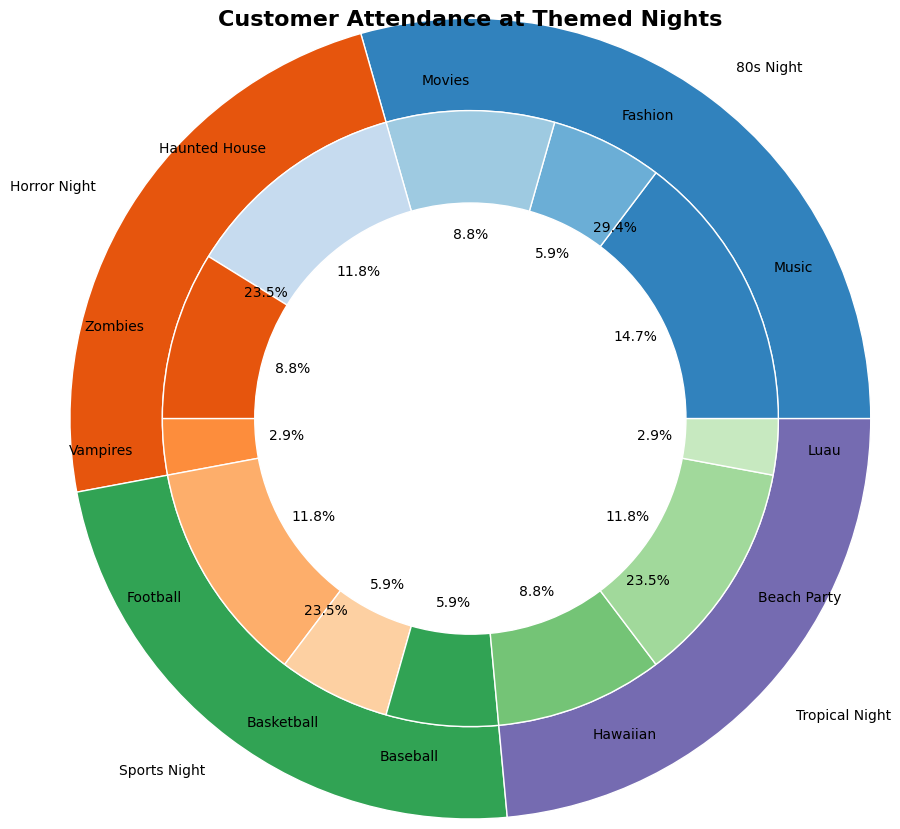Which theme has the highest overall attendance? To find the highest overall attendance, look at the outer pie chart. Compare the sizes of the slices labeled with the themes. The largest slice represents the theme with the highest attendance.
Answer: 80s Night What is the combined percentage of Music and Fashion sub-themes in 80s Night? First, find the percentages of the Music and Fashion sub-themes in the inner pie chart. Sum these percentages: Music (25%) + Fashion (10%) = 35%.
Answer: 35% Between Horror Night and Sports Night, which has a larger percentage of attendance overall? Compare the sizes of the outer slices labeled Horror Night and Sports Night. The larger slice indicates the theme with a higher percentage of attendance.
Answer: Horror Night What is the smallest sub-theme in terms of percentage, and which theme does it belong to? Identify the smallest slice in the inner ring, which represents the smallest sub-theme percentage. Check the label of this slice to find the sub-theme and its corresponding theme.
Answer: Vampires, Horror Night Compare the attendance of Hawaiian sub-theme and Baseball sub-theme. Which one is larger? Look at the sizes of the slices for the Hawaiian and Baseball sub-themes in the inner pie chart. The larger slice indicates the sub-theme with higher attendance.
Answer: Beach Party What is the total percentage of attendance for every Tropical Night sub-theme? Sum the percentages of all sub-themes under Tropical Night: Hawaiian (15%) + Beach Party (20%) + Luau (5%) = 40%.
Answer: 40% Is the combined attendance of Football and Basketball sub-themes more than the overall attendance of Horror Night? First, sum the percentages of the Football (20%) and Basketball (10%) sub-themes: 20% + 10% = 30%. Compare this sum to the overall attendance of Horror Night (40%).
Answer: No Which sub-theme constitutes the largest percentage in the Horror Night theme? Find the largest slice within the Horror Night portion of the inner pie chart and read its label.
Answer: Haunted House What percentage of customer attendance does the Luau sub-theme represent? Locate the Luau sub-theme slice in the inner pie chart and read its percentage.
Answer: 5% Compare the percentage of customers interested in Vampires on Horror Night to Movies on 80s Night. Which sub-theme has a higher attendance? Check the inner pie chart for the Vampires slice (5%) and Movies slice (15%). Compare these percentages.
Answer: Movies 